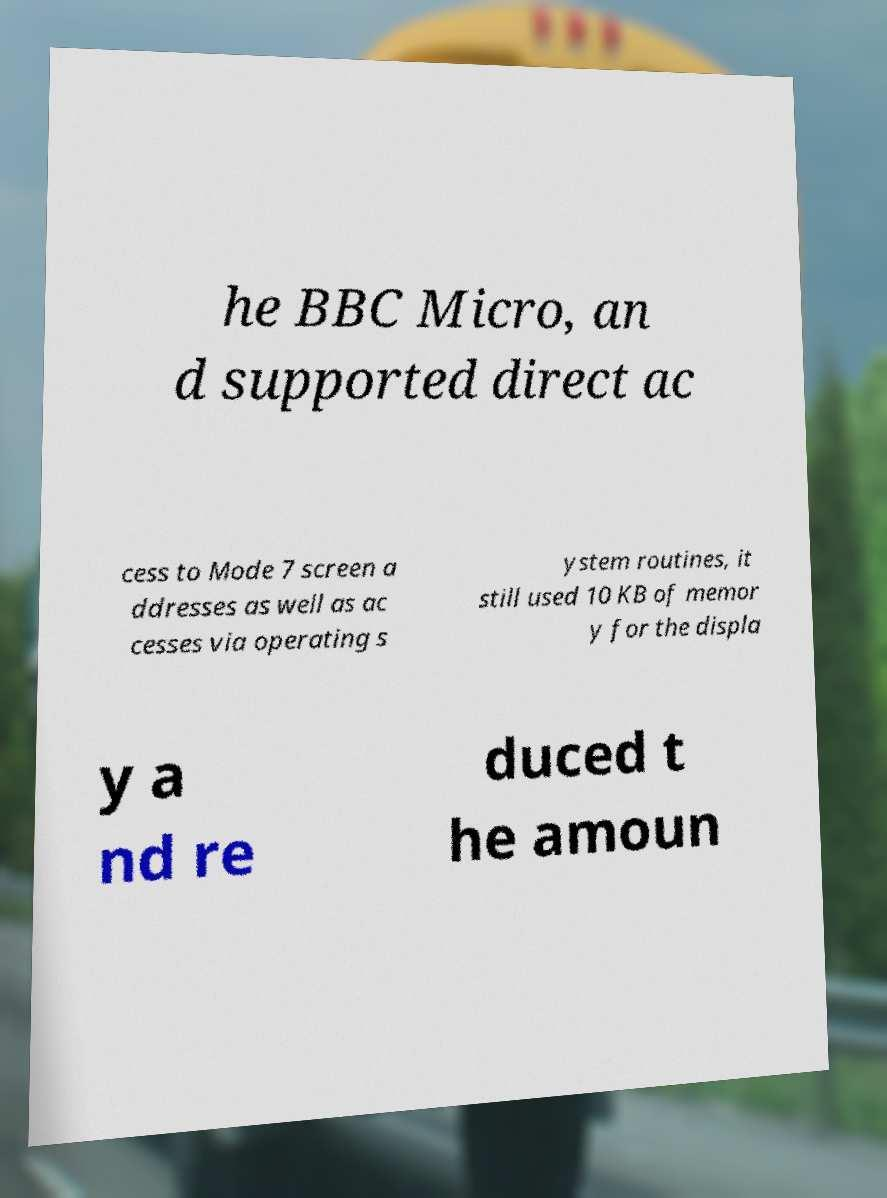I need the written content from this picture converted into text. Can you do that? he BBC Micro, an d supported direct ac cess to Mode 7 screen a ddresses as well as ac cesses via operating s ystem routines, it still used 10 KB of memor y for the displa y a nd re duced t he amoun 